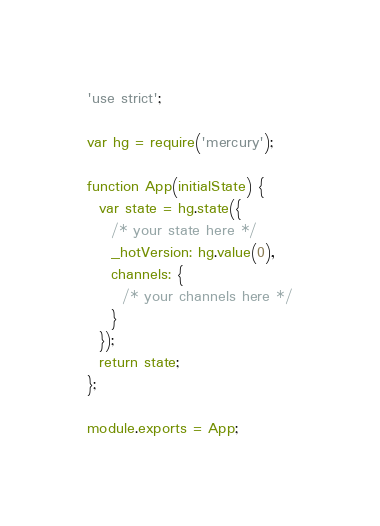<code> <loc_0><loc_0><loc_500><loc_500><_JavaScript_>'use strict';

var hg = require('mercury');

function App(initialState) {
  var state = hg.state({
    /* your state here */
    _hotVersion: hg.value(0),
    channels: {
      /* your channels here */
    }
  });
  return state;
};

module.exports = App;
</code> 